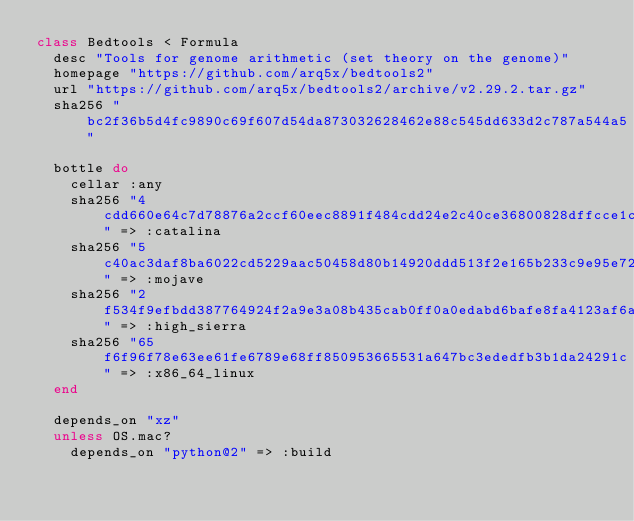<code> <loc_0><loc_0><loc_500><loc_500><_Ruby_>class Bedtools < Formula
  desc "Tools for genome arithmetic (set theory on the genome)"
  homepage "https://github.com/arq5x/bedtools2"
  url "https://github.com/arq5x/bedtools2/archive/v2.29.2.tar.gz"
  sha256 "bc2f36b5d4fc9890c69f607d54da873032628462e88c545dd633d2c787a544a5"

  bottle do
    cellar :any
    sha256 "4cdd660e64c7d78876a2ccf60eec8891f484cdd24e2c40ce36800828dffcce1c" => :catalina
    sha256 "5c40ac3daf8ba6022cd5229aac50458d80b14920ddd513f2e165b233c9e95e72" => :mojave
    sha256 "2f534f9efbdd387764924f2a9e3a08b435cab0ff0a0edabd6bafe8fa4123af6a" => :high_sierra
    sha256 "65f6f96f78e63ee61fe6789e68ff850953665531a647bc3ededfb3b1da24291c" => :x86_64_linux
  end

  depends_on "xz"
  unless OS.mac?
    depends_on "python@2" => :build</code> 